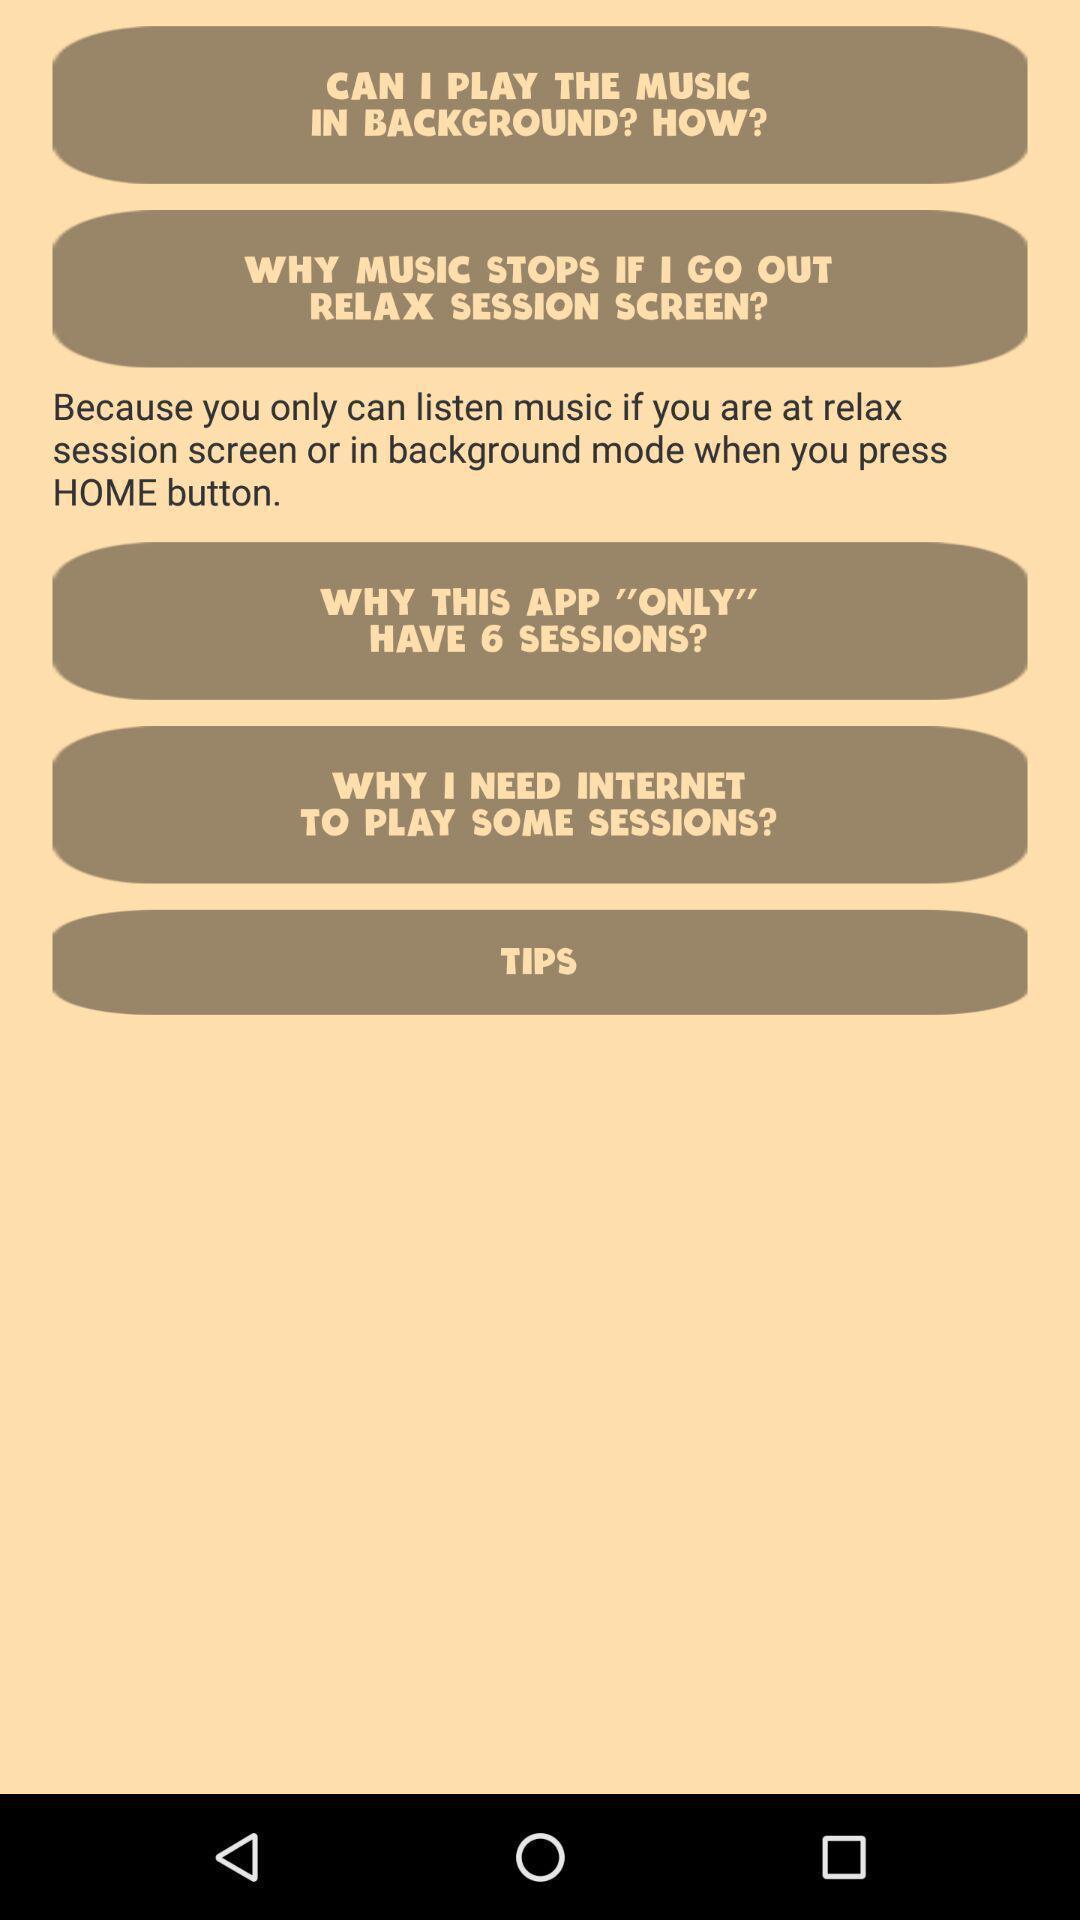Please provide a description for this image. Screen shows about music sessions. 